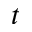Convert formula to latex. <formula><loc_0><loc_0><loc_500><loc_500>t</formula> 